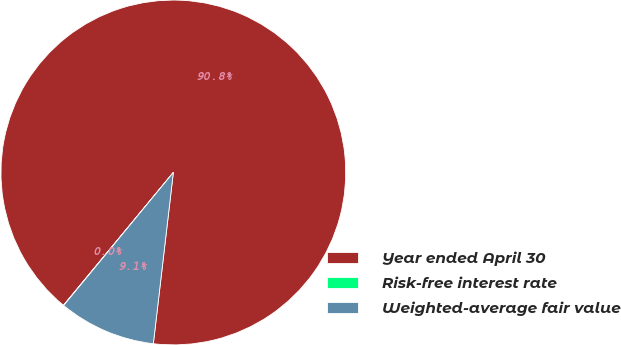<chart> <loc_0><loc_0><loc_500><loc_500><pie_chart><fcel>Year ended April 30<fcel>Risk-free interest rate<fcel>Weighted-average fair value<nl><fcel>90.85%<fcel>0.03%<fcel>9.12%<nl></chart> 